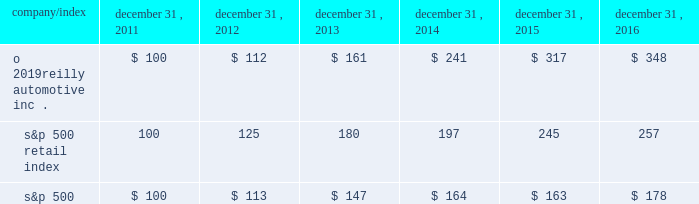Stock performance graph : the graph below shows the cumulative total shareholder return assuming the investment of $ 100 , on december 31 , 2011 , and the reinvestment of dividends thereafter , if any , in the company 2019s common stock versus the standard and poor 2019s s&p 500 retail index ( 201cs&p 500 retail index 201d ) and the standard and poor 2019s s&p 500 index ( 201cs&p 500 201d ) . .

What was the 2012 return on o 2019reilly automotive inc . stock?\\n? 
Computations: (112 - 100)
Answer: 12.0. 